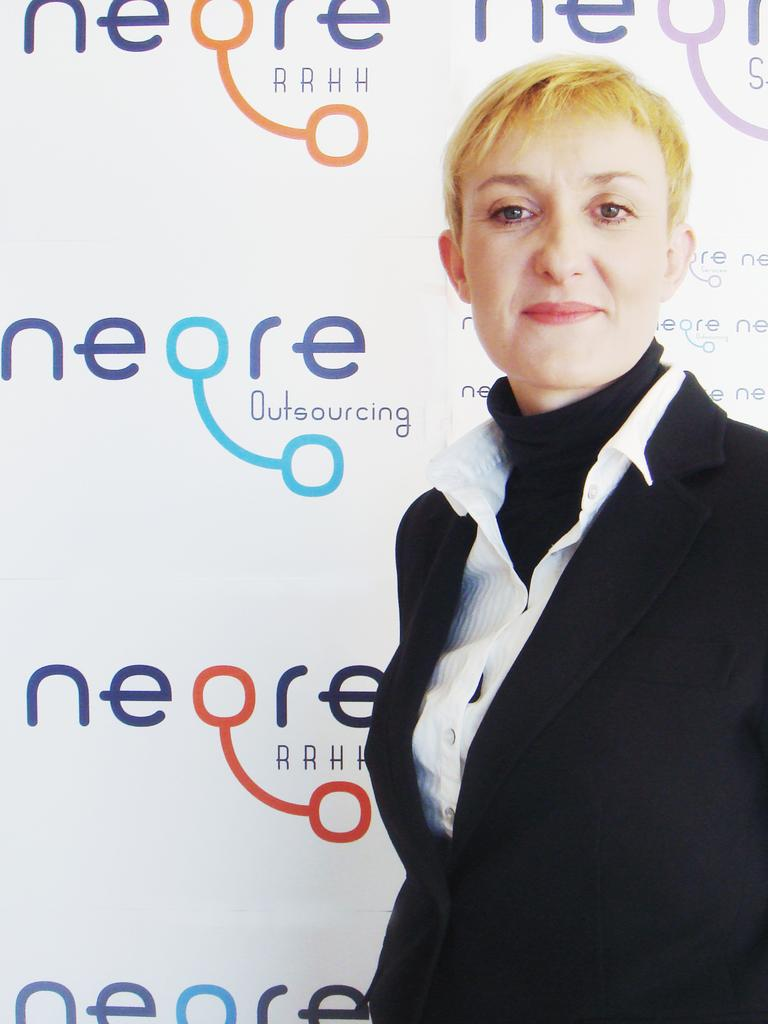What is the main subject of the image? The main subject of the image is a woman. What is the woman doing in the image? The woman is standing in the image. What is the woman's facial expression in the image? The woman is smiling in the image. What else can be seen in the image besides the woman? There is a banner visible in the image. What type of shoes is the woman wearing in the image? There is no information about the woman's shoes in the image. What is the woman's mind thinking about in the image? There is no information about the woman's thoughts in the image. 